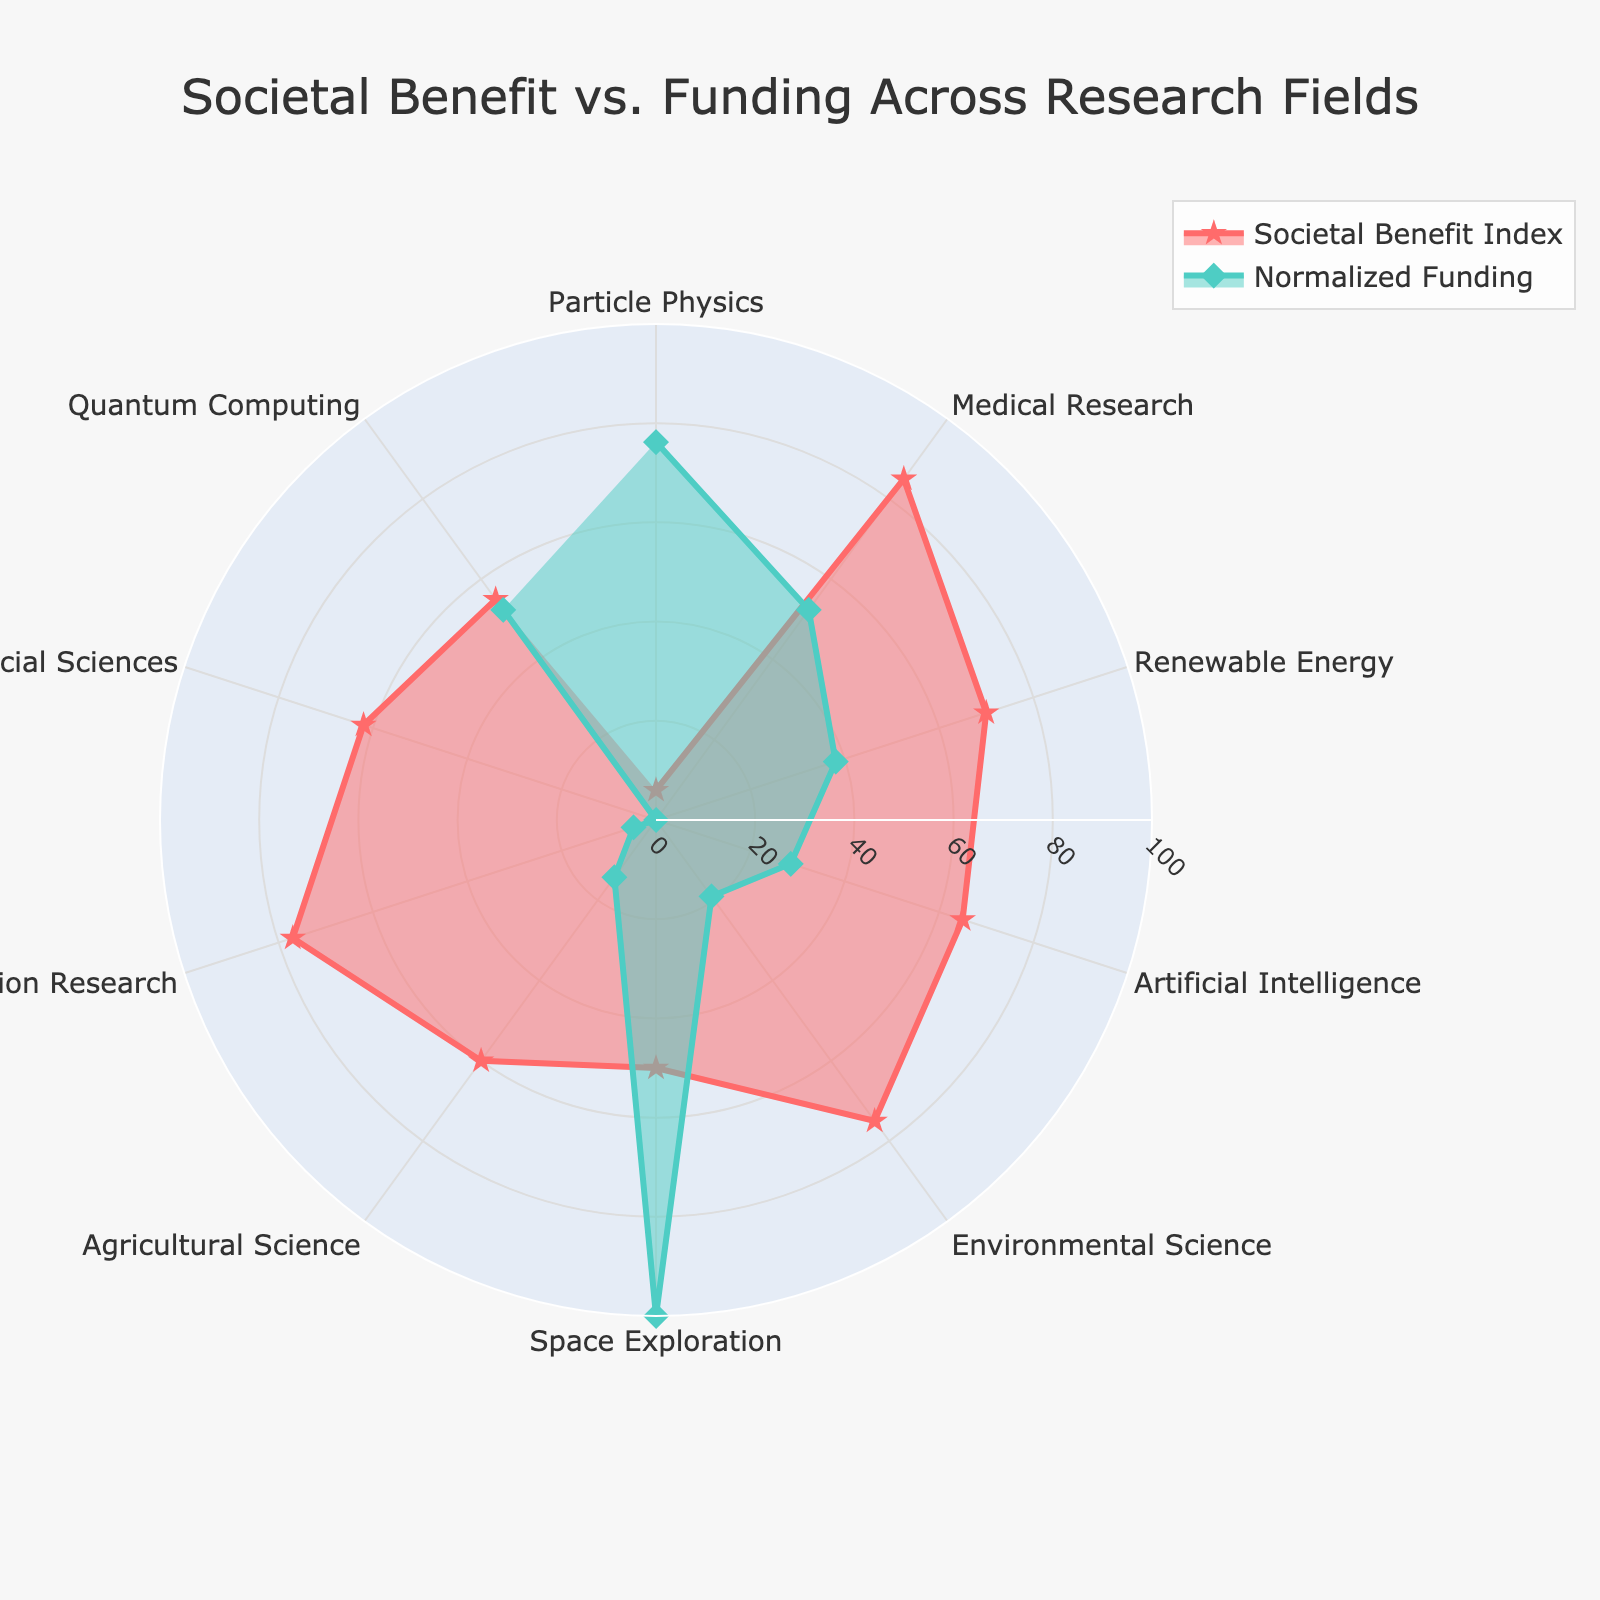what's the title of the plot? The title of the plot is located at the very top of the figure and typically provides a summary of what the chart represents. Reading the top of the figure will reveal that the title is "Societal Benefit vs. Funding Across Research Fields."
Answer: Societal Benefit vs. Funding Across Research Fields Which research field has the highest societal benefit index? To determine the highest societal benefit index, look for the value on the plot that reaches the outermost point on the "Societal Benefit Index" line (red line). "Medical Research" reaches approximately 85, which is the highest on the radar plot.
Answer: Medical Research What is the normalized funding for Particle Physics? In the radar chart, the green line represents the "Normalized Funding." Locate the segment labeled "Particle Physics" and check the green line's distance from the center to the edge. Based on the provided code, the funding is normalized to be between 0 and 100. The normalized value for Particle Physics is fairly low, approximately around 0.
Answer: 0 How does the normalized funding of "Space Exploration" compare to its societal benefit index? Identify the section labeled "Space Exploration" and compare the lengths of the two lines. The societal benefit (red line) for Space Exploration is around 50, while the normalized funding (green line) extends further out, suggesting a higher normalized funding.
Answer: Normalized funding is higher than the societal benefit index Is the societal benefit index for "Quantum Computing" higher or lower than "Agricultural Science"? Look at the plot sections for "Quantum Computing" and "Agricultural Science" and compare the lengths of the red lines. The societal benefit index for "Agricultural Science" is 60, whereas for "Quantum Computing," it is 55. Therefore, "Agricultural Science" has a higher societal benefit index than "Quantum Computing."
Answer: Lower What is the average societal benefit index for the research fields depicted in the plot? To find the average, list all societal benefit indexes from the plot: 6, 85, 70, 65, 75, 50, 60, 77, 62, 55. Sum these values (6+85+70+65+75+50+60+77+62+55 = 605) and divide by the number of fields (10). The average societal benefit index is 605/10.
Answer: 60.5 Which research field has the smallest difference between normalized funding and societal benefit index? Calculate the absolute difference between the normalized funding and the societal benefit index for each field. Particle Physics (0-6=6), Medical Research (85-100=15), Renewable Energy (70-80=10), Artificial Intelligence (65-80=15), Environmental Science (75-40=35), Space Exploration (90-50=40), Agricultural Science (30-60=30), Education Research (25-77=52), Social Sciences (40-62=22), Quantum Computing (100-55=45). The smallest difference is observed in Particle Physics.
Answer: Particle Physics 